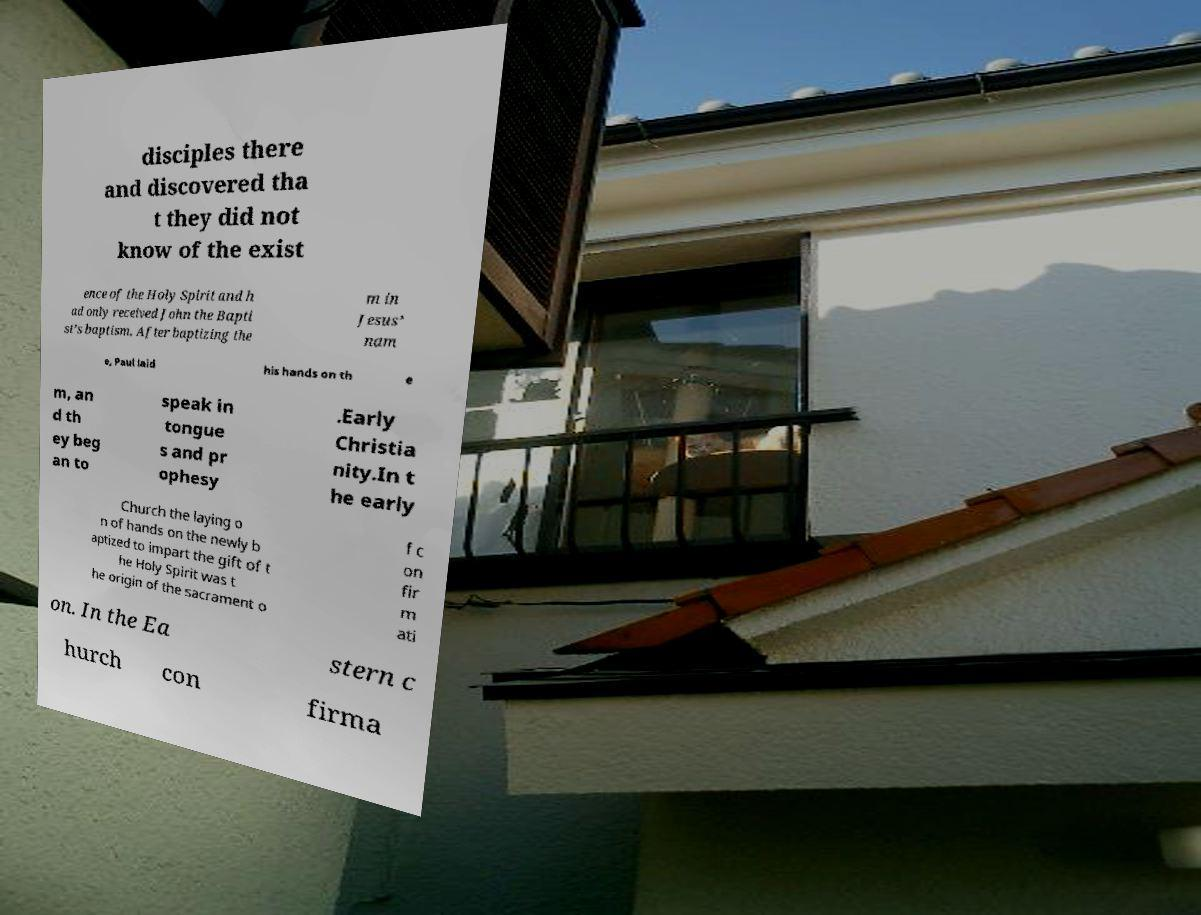Could you assist in decoding the text presented in this image and type it out clearly? disciples there and discovered tha t they did not know of the exist ence of the Holy Spirit and h ad only received John the Bapti st’s baptism. After baptizing the m in Jesus’ nam e, Paul laid his hands on th e m, an d th ey beg an to speak in tongue s and pr ophesy .Early Christia nity.In t he early Church the laying o n of hands on the newly b aptized to impart the gift of t he Holy Spirit was t he origin of the sacrament o f c on fir m ati on. In the Ea stern c hurch con firma 